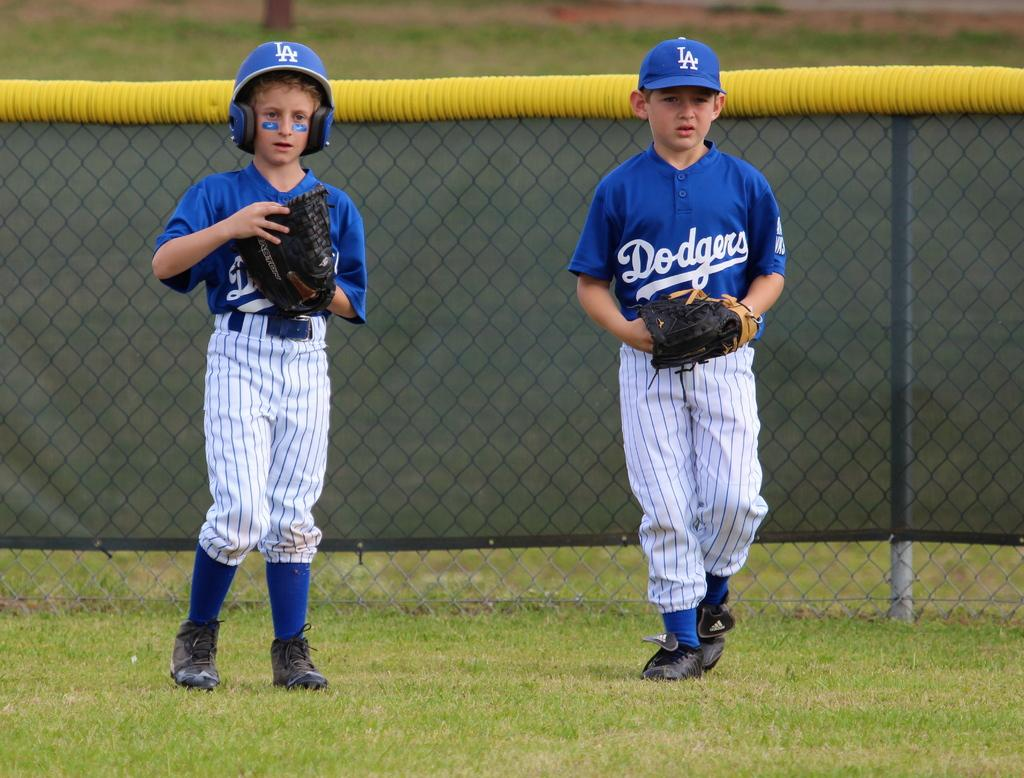<image>
Summarize the visual content of the image. Boy wearing a blue baseball jersey that says Dodgers on the field. 